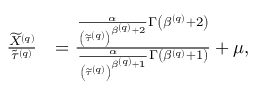<formula> <loc_0><loc_0><loc_500><loc_500>\begin{array} { r l } { \frac { \widetilde { X } ^ { \left ( q \right ) } } { \widetilde { \tau } ^ { \left ( q \right ) } } } & { = \frac { \frac { \alpha } { \left ( \widetilde { \tau } ^ { \left ( q \right ) } \right ) ^ { \beta ^ { \left ( q \right ) } + 2 } } \Gamma \left ( \beta ^ { \left ( q \right ) } + 2 \right ) } { \frac { \alpha } { \left ( \widetilde { \tau } ^ { \left ( q \right ) } \right ) ^ { \beta ^ { \left ( q \right ) } + 1 } } \Gamma \left ( \beta ^ { \left ( q \right ) } + 1 \right ) } + \mu , } \end{array}</formula> 